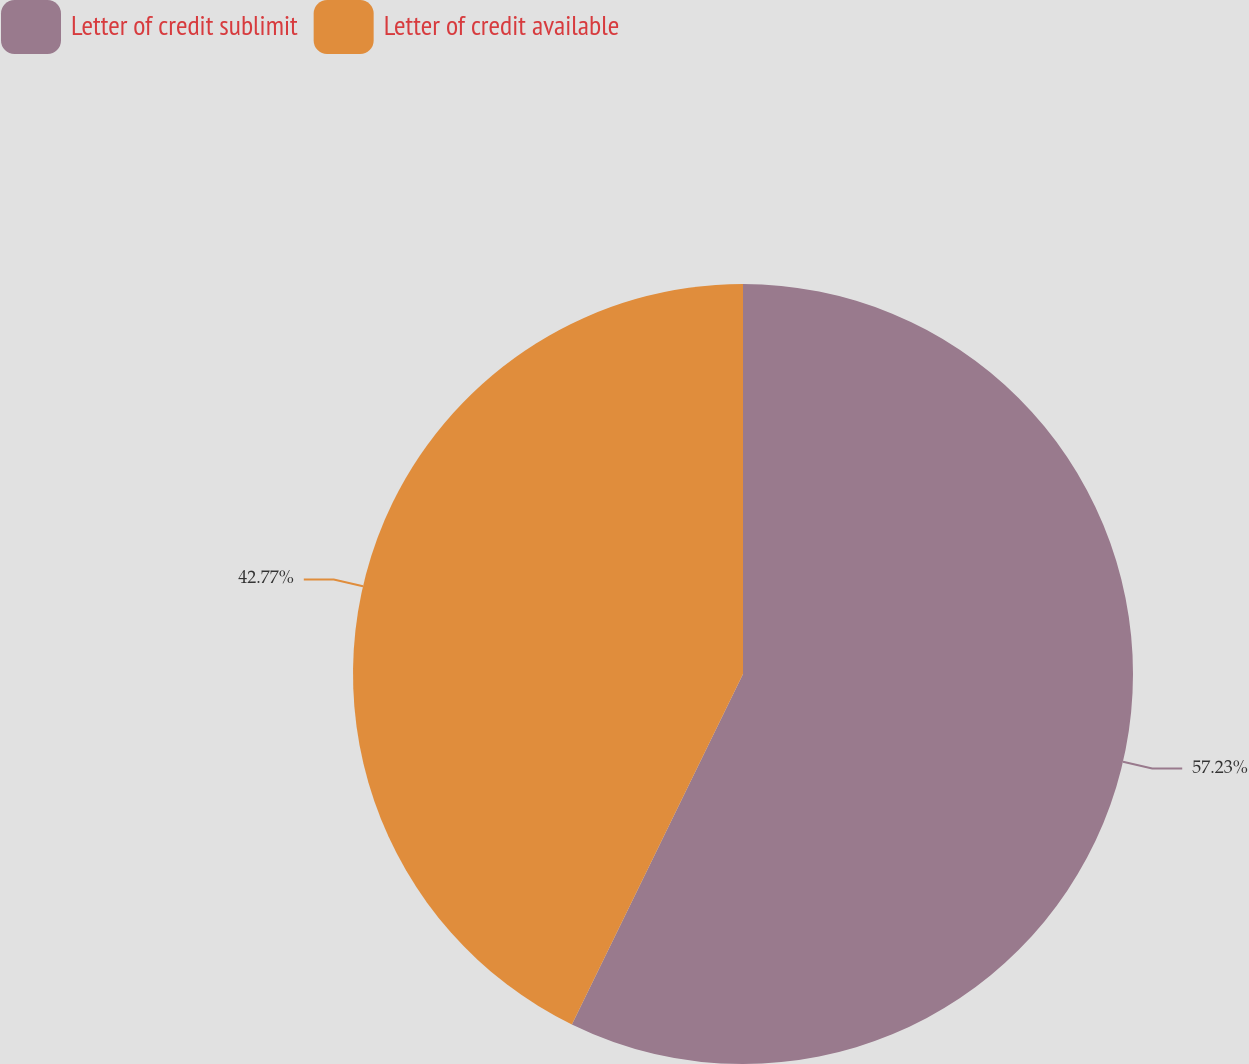Convert chart. <chart><loc_0><loc_0><loc_500><loc_500><pie_chart><fcel>Letter of credit sublimit<fcel>Letter of credit available<nl><fcel>57.23%<fcel>42.77%<nl></chart> 